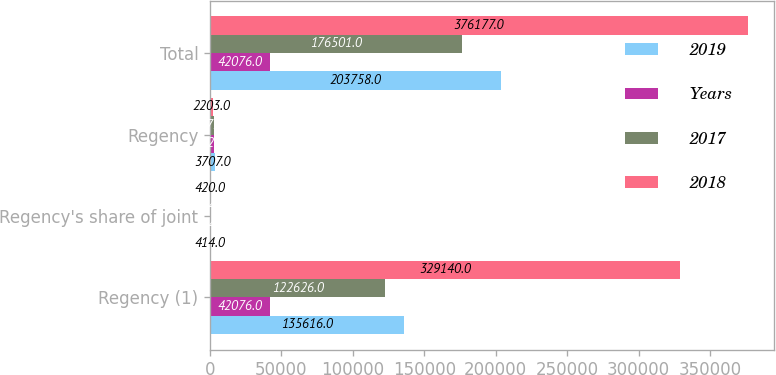<chart> <loc_0><loc_0><loc_500><loc_500><stacked_bar_chart><ecel><fcel>Regency (1)<fcel>Regency's share of joint<fcel>Regency<fcel>Total<nl><fcel>2019<fcel>135616<fcel>414<fcel>3707<fcel>203758<nl><fcel>Years<fcel>42076<fcel>414<fcel>2823<fcel>42076<nl><fcel>2017<fcel>122626<fcel>414<fcel>2475<fcel>176501<nl><fcel>2018<fcel>329140<fcel>420<fcel>2203<fcel>376177<nl></chart> 